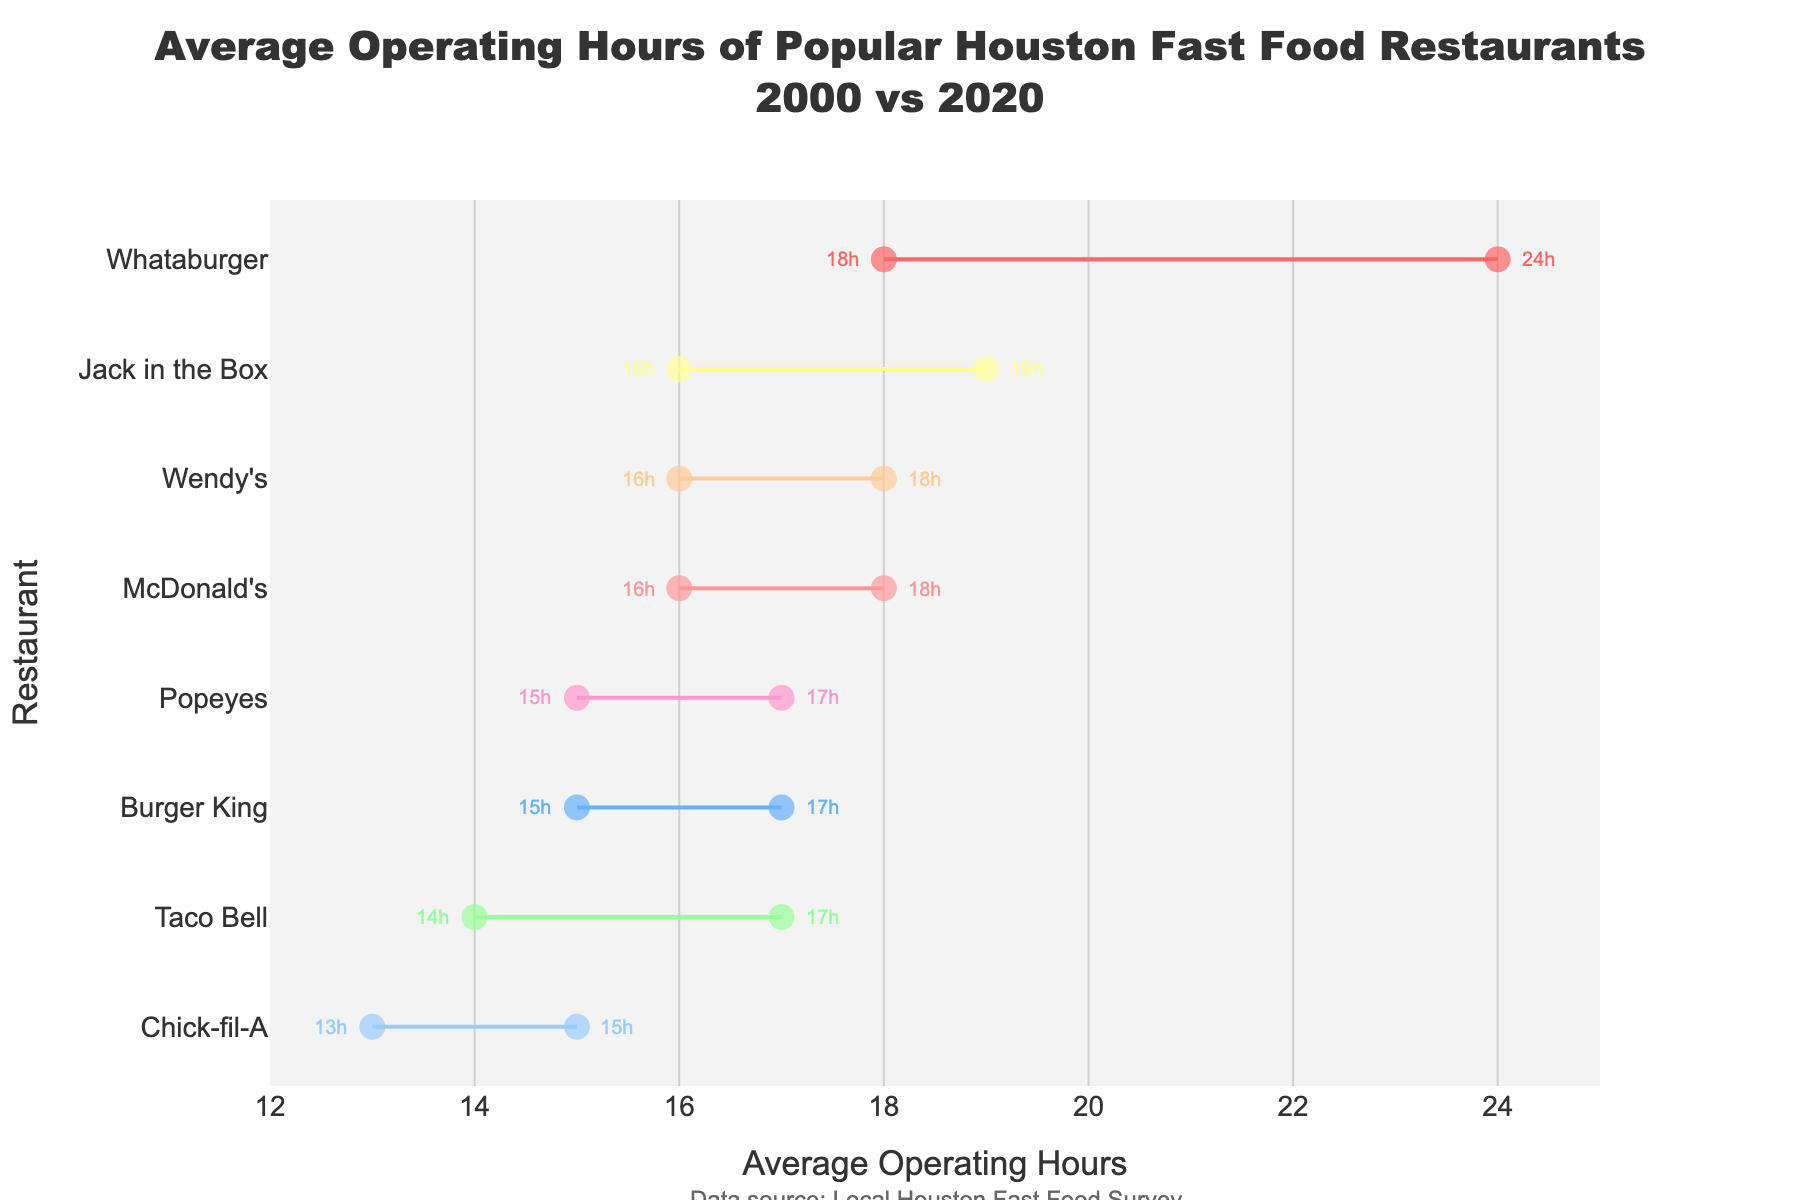What's the main title of the figure? The main title of the figure is displayed prominently at the top of the plot and usually includes the subject and time frame of the data. The title reads: "Average Operating Hours of Popular Houston Fast Food Restaurants 2000 vs 2020"
Answer: Average Operating Hours of Popular Houston Fast Food Restaurants 2000 vs 2020 What color represents McDonald's in the plot? The restaurant's color is indicated by its markers and lines. McDonald's is the first entry, and it corresponds with the first color in the list used: a shade of red.
Answer: Red Which restaurant had the biggest increase in operating hours from 2000 to 2020? The difference in operating hours is represented by the length of the line connecting the markers for each year. Whataburger increased the most, from 18 hours in 2000 to 24 hours in 2020.
Answer: Whataburger How many data points are displayed for each restaurant? Each restaurant has two data points: one for the year 2000 and one for 2020, indicated by the two markers connected by a line.
Answer: 2 Which restaurant operated for the fewest hours in 2000? To find this, look for the marker on the leftmost side of the 2000 markers. Chick-fil-A had the fewest operating hours, at 13 hours.
Answer: Chick-fil-A What’s the average operating time for Jack in the Box across the two years? Sum the operating hours from 2000 and 2020 for Jack in the Box and divide by 2: (16 + 19) / 2 = 17.5 hours.
Answer: 17.5 hours Which restaurant showed an equal increase in operating hours from 2000 to 2020? Compare the difference in operating hours for each restaurant. McDonald's, Burger King, and Popeyes all increased by 2 hours (16 to 18, 15 to 17, and 15 to 17, respectively).
Answer: McDonald's, Burger King, Popeyes Which restaurant had the highest operating hours in 2020? Look for the rightmost marker in the 2020 data. Whataburger had the highest operating hours at 24 hours.
Answer: Whataburger Is there any restaurant that didn’t change its operating hours from 2000 to 2020? Check if any restaurant has markers at the same position for both years. All restaurants show an increase in operating hours, so none stayed the same.
Answer: No Which restaurant operates for more hours, Wendy's or Taco Bell, in 2020? Compare their 2020 markers: Wendy's operates for 18 hours and Taco Bell operates for 17 hours. Wendy's operates for more hours.
Answer: Wendy's 